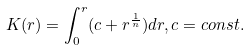Convert formula to latex. <formula><loc_0><loc_0><loc_500><loc_500>K ( r ) = \int _ { 0 } ^ { r } ( c + r ^ { \frac { 1 } { n } } ) d r , c = c o n s t .</formula> 